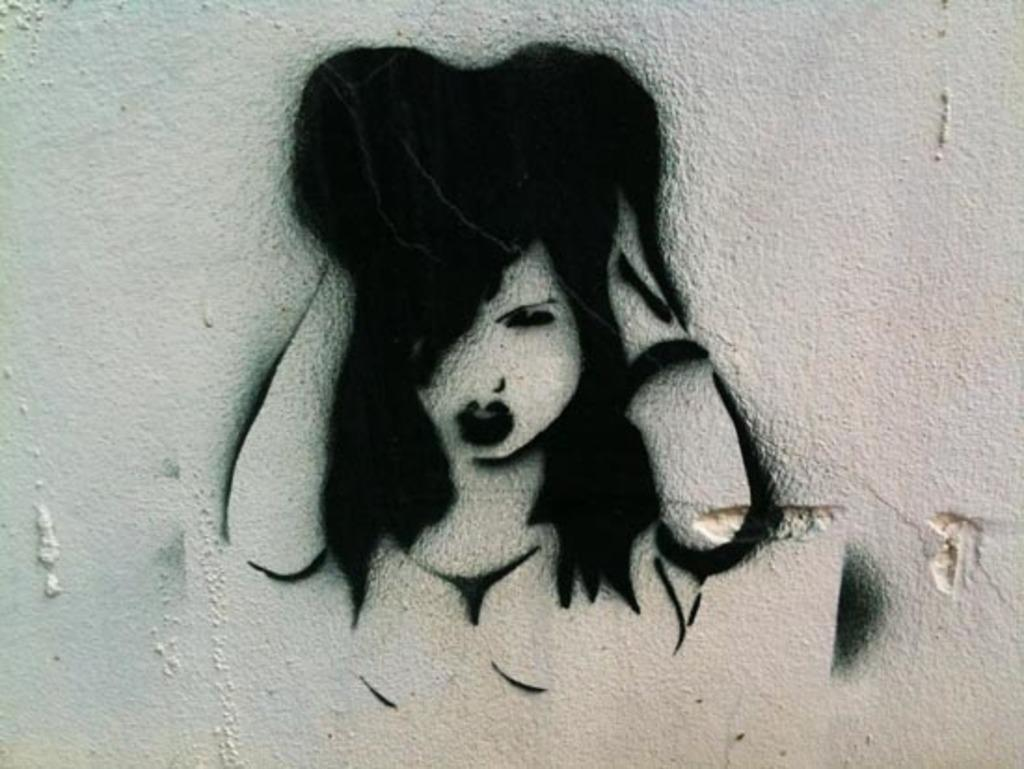What type of artwork is depicted in the image? The image is a graffiti. What is the background of the graffiti? The graffiti is painted on a white wall. What type of attraction is featured in the graffiti? There is no attraction depicted in the graffiti; it is an artistic expression on a white wall. Can you see a tramp in the graffiti? There is no tramp present in the graffiti; it is a painting on a white wall. 